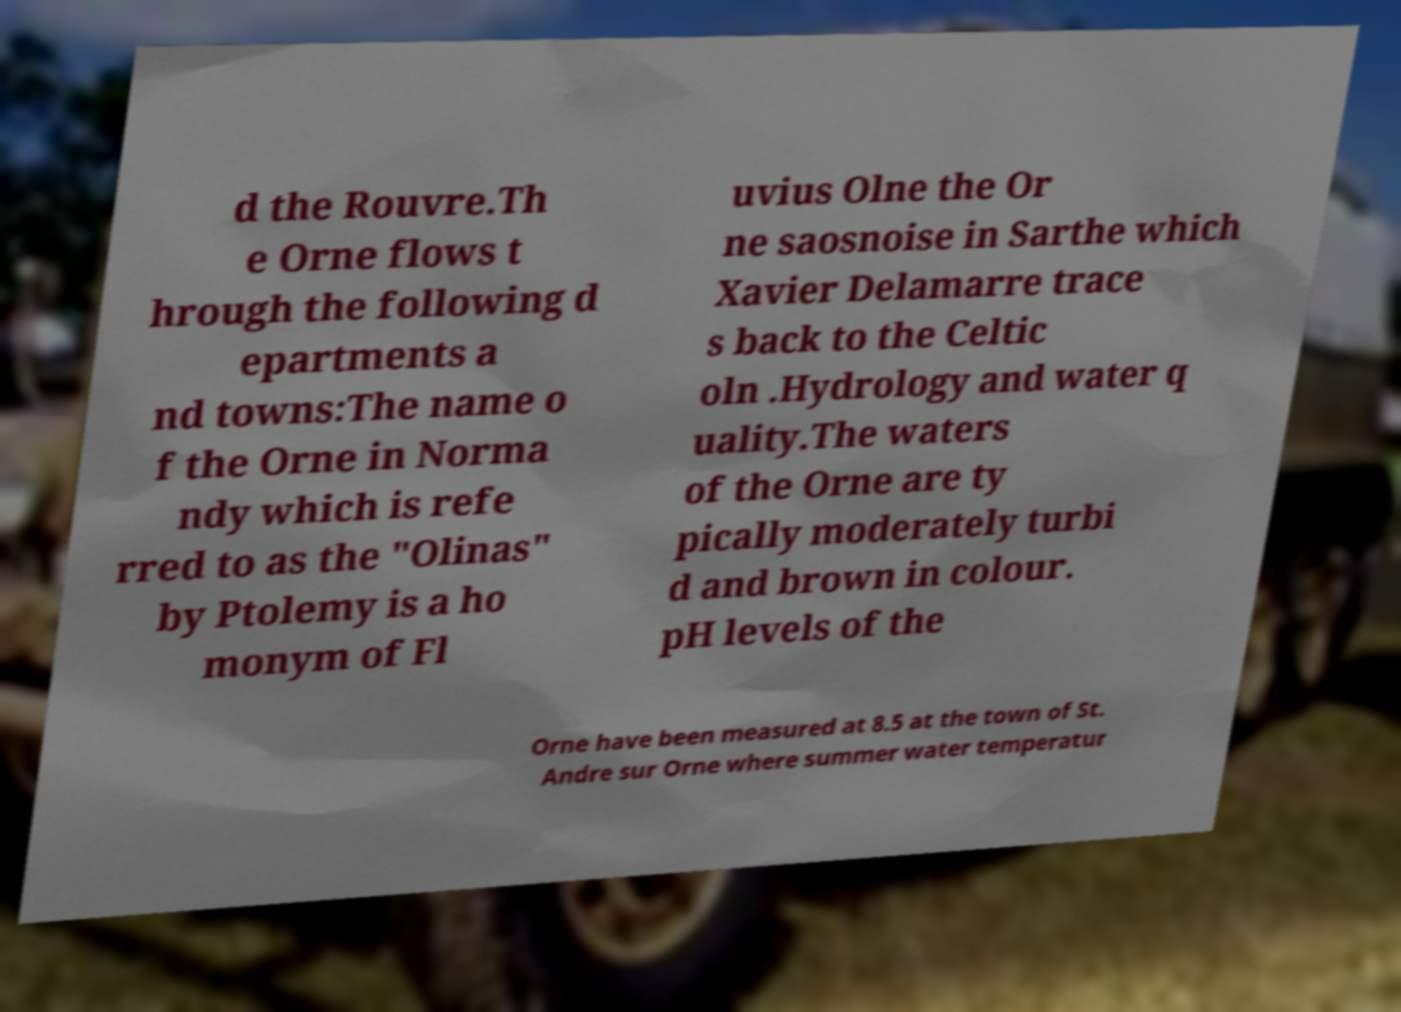Can you read and provide the text displayed in the image?This photo seems to have some interesting text. Can you extract and type it out for me? d the Rouvre.Th e Orne flows t hrough the following d epartments a nd towns:The name o f the Orne in Norma ndy which is refe rred to as the "Olinas" by Ptolemy is a ho monym of Fl uvius Olne the Or ne saosnoise in Sarthe which Xavier Delamarre trace s back to the Celtic oln .Hydrology and water q uality.The waters of the Orne are ty pically moderately turbi d and brown in colour. pH levels of the Orne have been measured at 8.5 at the town of St. Andre sur Orne where summer water temperatur 